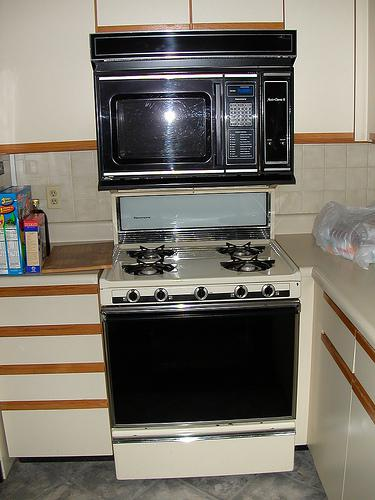Question: what is that on the left of the stove?
Choices:
A. Milk containers.
B. Cereal boxes.
C. Spices.
D. Cake dough.
Answer with the letter. Answer: B Question: what is that above the stove?
Choices:
A. A smoke ventilator.
B. A microwave.
C. A shelf with spices.
D. A painting.
Answer with the letter. Answer: B Question: where was this picture taken?
Choices:
A. In the bedroom.
B. In the house.
C. In the backyard.
D. In the kitchen.
Answer with the letter. Answer: D 